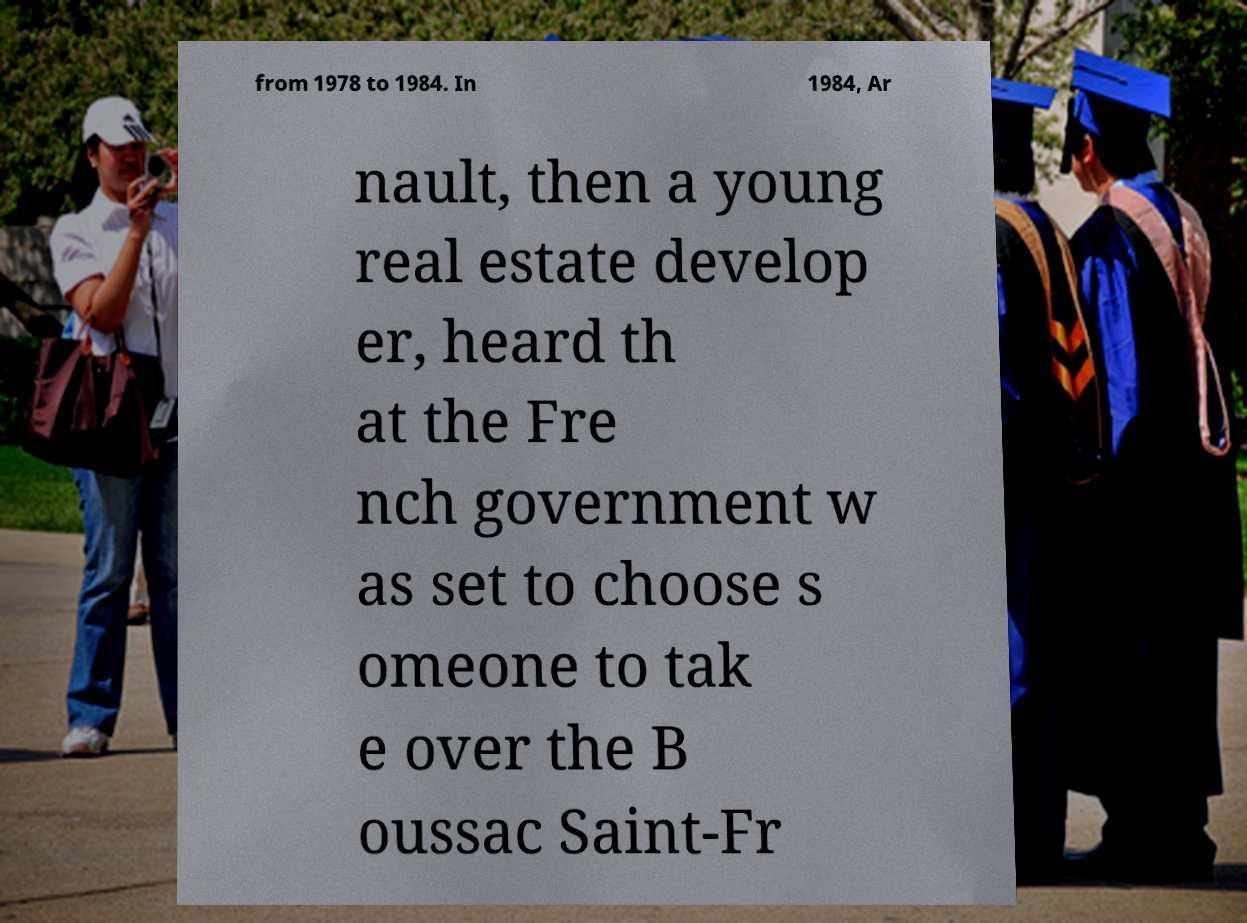Can you accurately transcribe the text from the provided image for me? from 1978 to 1984. In 1984, Ar nault, then a young real estate develop er, heard th at the Fre nch government w as set to choose s omeone to tak e over the B oussac Saint-Fr 